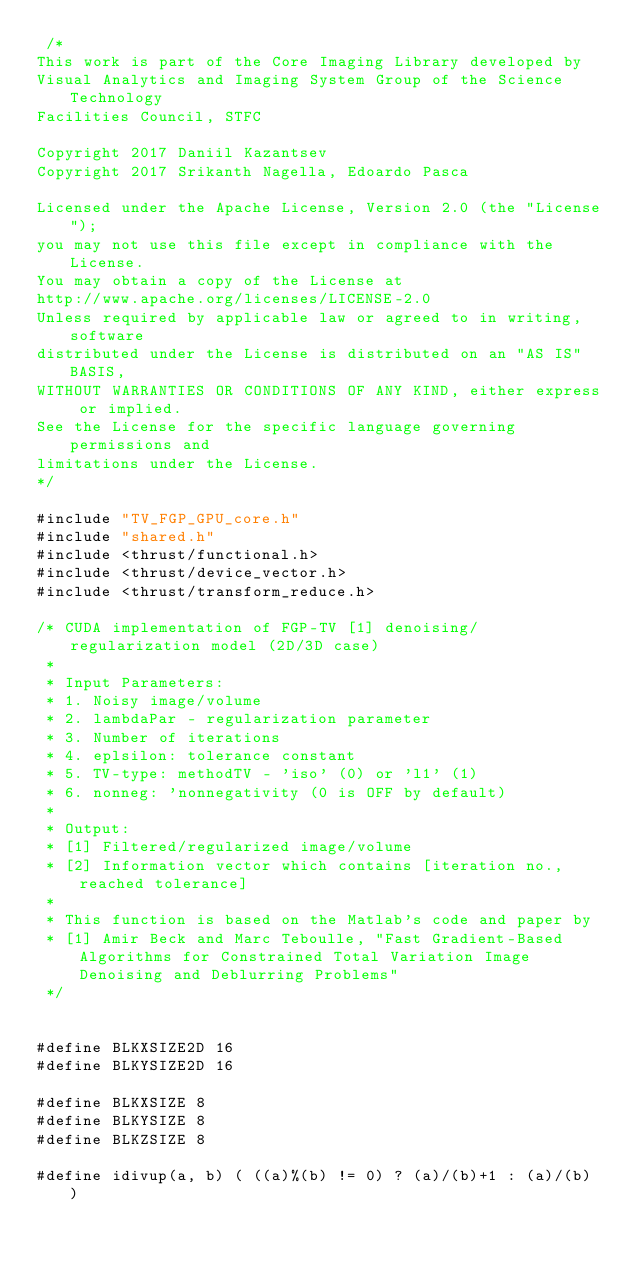Convert code to text. <code><loc_0><loc_0><loc_500><loc_500><_Cuda_> /*
This work is part of the Core Imaging Library developed by
Visual Analytics and Imaging System Group of the Science Technology
Facilities Council, STFC

Copyright 2017 Daniil Kazantsev
Copyright 2017 Srikanth Nagella, Edoardo Pasca

Licensed under the Apache License, Version 2.0 (the "License");
you may not use this file except in compliance with the License.
You may obtain a copy of the License at
http://www.apache.org/licenses/LICENSE-2.0
Unless required by applicable law or agreed to in writing, software
distributed under the License is distributed on an "AS IS" BASIS,
WITHOUT WARRANTIES OR CONDITIONS OF ANY KIND, either express or implied.
See the License for the specific language governing permissions and
limitations under the License.
*/

#include "TV_FGP_GPU_core.h"
#include "shared.h"
#include <thrust/functional.h>
#include <thrust/device_vector.h>
#include <thrust/transform_reduce.h>

/* CUDA implementation of FGP-TV [1] denoising/regularization model (2D/3D case)
 *
 * Input Parameters:
 * 1. Noisy image/volume
 * 2. lambdaPar - regularization parameter
 * 3. Number of iterations
 * 4. eplsilon: tolerance constant
 * 5. TV-type: methodTV - 'iso' (0) or 'l1' (1)
 * 6. nonneg: 'nonnegativity (0 is OFF by default)
 *
 * Output:
 * [1] Filtered/regularized image/volume
 * [2] Information vector which contains [iteration no., reached tolerance]
 *
 * This function is based on the Matlab's code and paper by
 * [1] Amir Beck and Marc Teboulle, "Fast Gradient-Based Algorithms for Constrained Total Variation Image Denoising and Deblurring Problems"
 */


#define BLKXSIZE2D 16
#define BLKYSIZE2D 16

#define BLKXSIZE 8
#define BLKYSIZE 8
#define BLKZSIZE 8

#define idivup(a, b) ( ((a)%(b) != 0) ? (a)/(b)+1 : (a)/(b) )</code> 